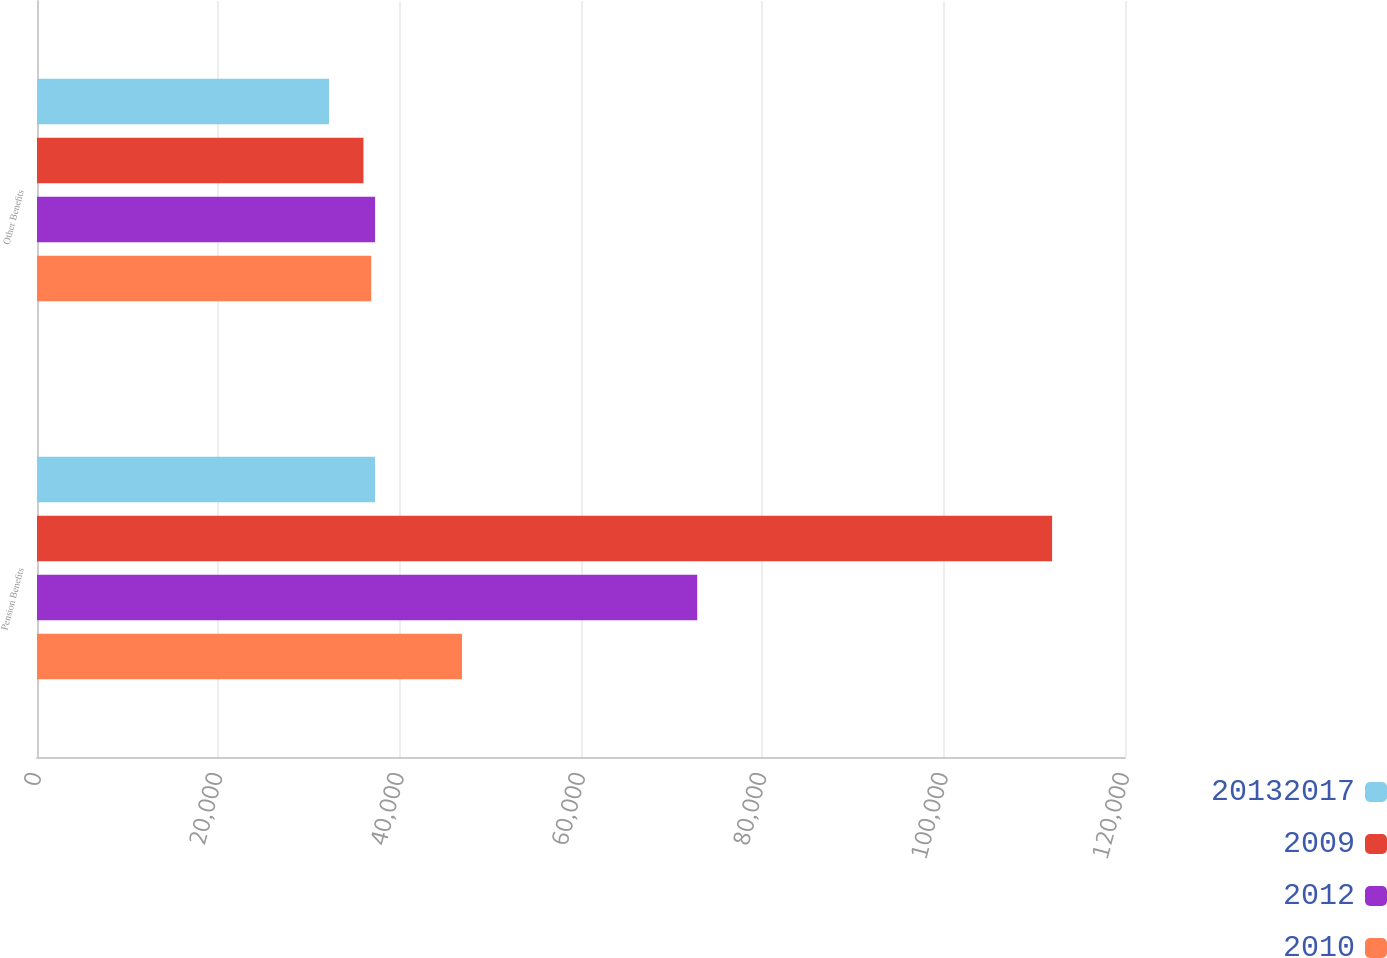<chart> <loc_0><loc_0><loc_500><loc_500><stacked_bar_chart><ecel><fcel>Pension Benefits<fcel>Other Benefits<nl><fcel>2.0132e+07<fcel>37286<fcel>32208<nl><fcel>2009<fcel>111960<fcel>36006<nl><fcel>2012<fcel>72819<fcel>37286<nl><fcel>2010<fcel>46877<fcel>36861<nl></chart> 